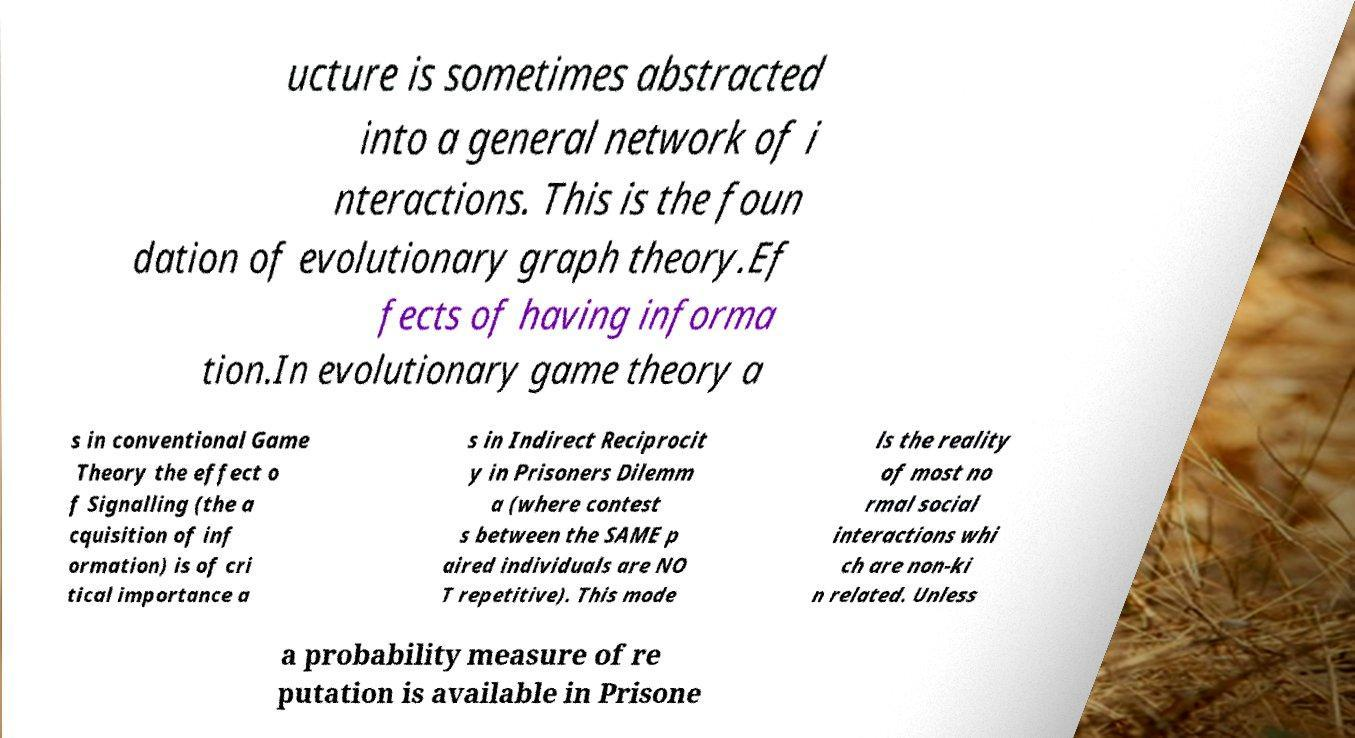Could you extract and type out the text from this image? ucture is sometimes abstracted into a general network of i nteractions. This is the foun dation of evolutionary graph theory.Ef fects of having informa tion.In evolutionary game theory a s in conventional Game Theory the effect o f Signalling (the a cquisition of inf ormation) is of cri tical importance a s in Indirect Reciprocit y in Prisoners Dilemm a (where contest s between the SAME p aired individuals are NO T repetitive). This mode ls the reality of most no rmal social interactions whi ch are non-ki n related. Unless a probability measure of re putation is available in Prisone 